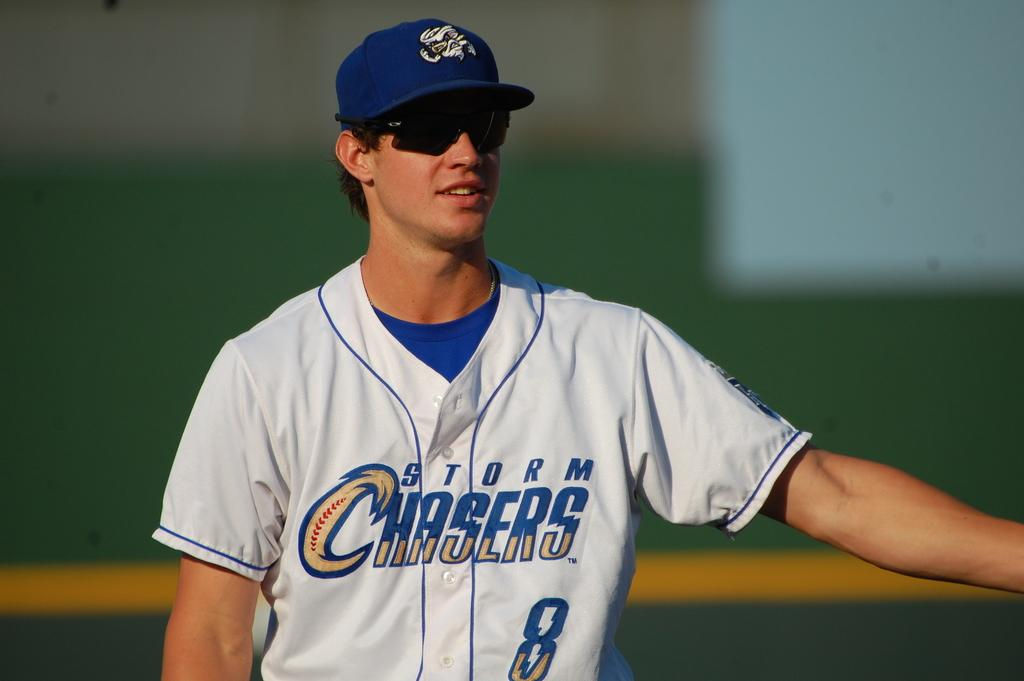<image>
Present a compact description of the photo's key features. a player that is wearing a Chasers uniform 